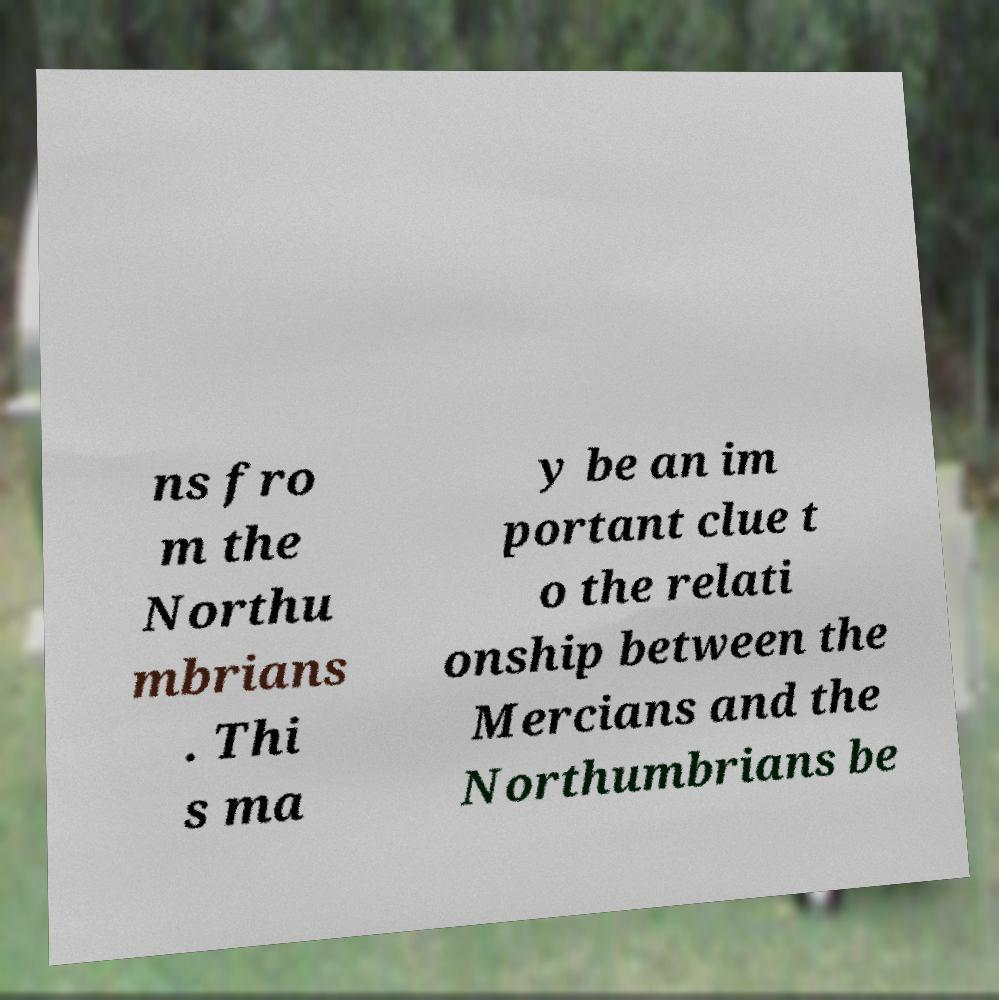For documentation purposes, I need the text within this image transcribed. Could you provide that? ns fro m the Northu mbrians . Thi s ma y be an im portant clue t o the relati onship between the Mercians and the Northumbrians be 